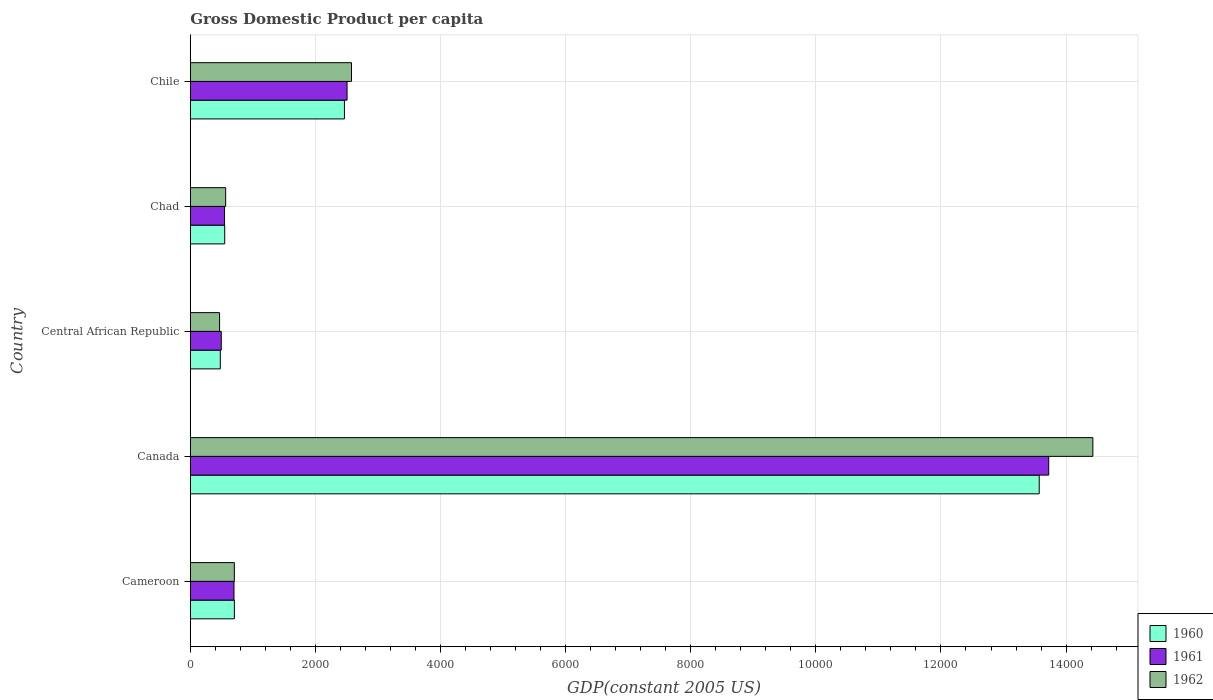How many groups of bars are there?
Your answer should be compact. 5. Are the number of bars on each tick of the Y-axis equal?
Your answer should be very brief. Yes. How many bars are there on the 5th tick from the bottom?
Ensure brevity in your answer.  3. What is the label of the 3rd group of bars from the top?
Offer a terse response. Central African Republic. What is the GDP per capita in 1961 in Cameroon?
Provide a short and direct response. 698.37. Across all countries, what is the maximum GDP per capita in 1960?
Keep it short and to the point. 1.36e+04. Across all countries, what is the minimum GDP per capita in 1962?
Make the answer very short. 468.21. In which country was the GDP per capita in 1962 minimum?
Keep it short and to the point. Central African Republic. What is the total GDP per capita in 1962 in the graph?
Keep it short and to the point. 1.87e+04. What is the difference between the GDP per capita in 1961 in Cameroon and that in Central African Republic?
Give a very brief answer. 203.38. What is the difference between the GDP per capita in 1962 in Central African Republic and the GDP per capita in 1960 in Canada?
Offer a terse response. -1.31e+04. What is the average GDP per capita in 1960 per country?
Ensure brevity in your answer.  3553.91. What is the difference between the GDP per capita in 1960 and GDP per capita in 1962 in Canada?
Ensure brevity in your answer.  -857.65. What is the ratio of the GDP per capita in 1961 in Cameroon to that in Central African Republic?
Your answer should be very brief. 1.41. Is the GDP per capita in 1960 in Canada less than that in Central African Republic?
Provide a short and direct response. No. Is the difference between the GDP per capita in 1960 in Canada and Chad greater than the difference between the GDP per capita in 1962 in Canada and Chad?
Give a very brief answer. No. What is the difference between the highest and the second highest GDP per capita in 1961?
Keep it short and to the point. 1.12e+04. What is the difference between the highest and the lowest GDP per capita in 1962?
Provide a short and direct response. 1.40e+04. Is the sum of the GDP per capita in 1960 in Central African Republic and Chad greater than the maximum GDP per capita in 1961 across all countries?
Your answer should be very brief. No. What does the 2nd bar from the top in Cameroon represents?
Your answer should be compact. 1961. What does the 1st bar from the bottom in Canada represents?
Offer a terse response. 1960. How many bars are there?
Ensure brevity in your answer.  15. How many countries are there in the graph?
Provide a succinct answer. 5. Does the graph contain any zero values?
Provide a succinct answer. No. Where does the legend appear in the graph?
Offer a terse response. Bottom right. What is the title of the graph?
Your response must be concise. Gross Domestic Product per capita. Does "2015" appear as one of the legend labels in the graph?
Keep it short and to the point. No. What is the label or title of the X-axis?
Give a very brief answer. GDP(constant 2005 US). What is the label or title of the Y-axis?
Give a very brief answer. Country. What is the GDP(constant 2005 US) in 1960 in Cameroon?
Offer a very short reply. 704.77. What is the GDP(constant 2005 US) in 1961 in Cameroon?
Your response must be concise. 698.37. What is the GDP(constant 2005 US) in 1962 in Cameroon?
Provide a short and direct response. 704.27. What is the GDP(constant 2005 US) in 1960 in Canada?
Provide a succinct answer. 1.36e+04. What is the GDP(constant 2005 US) of 1961 in Canada?
Provide a succinct answer. 1.37e+04. What is the GDP(constant 2005 US) of 1962 in Canada?
Your answer should be compact. 1.44e+04. What is the GDP(constant 2005 US) in 1960 in Central African Republic?
Your answer should be very brief. 479.7. What is the GDP(constant 2005 US) of 1961 in Central African Republic?
Keep it short and to the point. 494.99. What is the GDP(constant 2005 US) of 1962 in Central African Republic?
Make the answer very short. 468.21. What is the GDP(constant 2005 US) of 1960 in Chad?
Your answer should be compact. 550.24. What is the GDP(constant 2005 US) in 1961 in Chad?
Your response must be concise. 547.21. What is the GDP(constant 2005 US) in 1962 in Chad?
Your answer should be very brief. 565.29. What is the GDP(constant 2005 US) of 1960 in Chile?
Provide a short and direct response. 2464.15. What is the GDP(constant 2005 US) in 1961 in Chile?
Keep it short and to the point. 2506.04. What is the GDP(constant 2005 US) of 1962 in Chile?
Offer a very short reply. 2577.05. Across all countries, what is the maximum GDP(constant 2005 US) of 1960?
Your answer should be very brief. 1.36e+04. Across all countries, what is the maximum GDP(constant 2005 US) of 1961?
Keep it short and to the point. 1.37e+04. Across all countries, what is the maximum GDP(constant 2005 US) in 1962?
Give a very brief answer. 1.44e+04. Across all countries, what is the minimum GDP(constant 2005 US) in 1960?
Offer a very short reply. 479.7. Across all countries, what is the minimum GDP(constant 2005 US) in 1961?
Provide a succinct answer. 494.99. Across all countries, what is the minimum GDP(constant 2005 US) of 1962?
Ensure brevity in your answer.  468.21. What is the total GDP(constant 2005 US) of 1960 in the graph?
Offer a very short reply. 1.78e+04. What is the total GDP(constant 2005 US) of 1961 in the graph?
Make the answer very short. 1.80e+04. What is the total GDP(constant 2005 US) in 1962 in the graph?
Your response must be concise. 1.87e+04. What is the difference between the GDP(constant 2005 US) of 1960 in Cameroon and that in Canada?
Give a very brief answer. -1.29e+04. What is the difference between the GDP(constant 2005 US) in 1961 in Cameroon and that in Canada?
Make the answer very short. -1.30e+04. What is the difference between the GDP(constant 2005 US) of 1962 in Cameroon and that in Canada?
Provide a succinct answer. -1.37e+04. What is the difference between the GDP(constant 2005 US) in 1960 in Cameroon and that in Central African Republic?
Offer a very short reply. 225.07. What is the difference between the GDP(constant 2005 US) in 1961 in Cameroon and that in Central African Republic?
Offer a very short reply. 203.38. What is the difference between the GDP(constant 2005 US) of 1962 in Cameroon and that in Central African Republic?
Your answer should be compact. 236.06. What is the difference between the GDP(constant 2005 US) in 1960 in Cameroon and that in Chad?
Offer a very short reply. 154.53. What is the difference between the GDP(constant 2005 US) in 1961 in Cameroon and that in Chad?
Give a very brief answer. 151.16. What is the difference between the GDP(constant 2005 US) of 1962 in Cameroon and that in Chad?
Provide a succinct answer. 138.98. What is the difference between the GDP(constant 2005 US) of 1960 in Cameroon and that in Chile?
Provide a succinct answer. -1759.38. What is the difference between the GDP(constant 2005 US) in 1961 in Cameroon and that in Chile?
Provide a short and direct response. -1807.67. What is the difference between the GDP(constant 2005 US) of 1962 in Cameroon and that in Chile?
Provide a short and direct response. -1872.78. What is the difference between the GDP(constant 2005 US) of 1960 in Canada and that in Central African Republic?
Ensure brevity in your answer.  1.31e+04. What is the difference between the GDP(constant 2005 US) in 1961 in Canada and that in Central African Republic?
Keep it short and to the point. 1.32e+04. What is the difference between the GDP(constant 2005 US) in 1962 in Canada and that in Central African Republic?
Your answer should be very brief. 1.40e+04. What is the difference between the GDP(constant 2005 US) in 1960 in Canada and that in Chad?
Provide a succinct answer. 1.30e+04. What is the difference between the GDP(constant 2005 US) in 1961 in Canada and that in Chad?
Give a very brief answer. 1.32e+04. What is the difference between the GDP(constant 2005 US) in 1962 in Canada and that in Chad?
Offer a very short reply. 1.39e+04. What is the difference between the GDP(constant 2005 US) of 1960 in Canada and that in Chile?
Make the answer very short. 1.11e+04. What is the difference between the GDP(constant 2005 US) of 1961 in Canada and that in Chile?
Give a very brief answer. 1.12e+04. What is the difference between the GDP(constant 2005 US) in 1962 in Canada and that in Chile?
Your answer should be compact. 1.19e+04. What is the difference between the GDP(constant 2005 US) of 1960 in Central African Republic and that in Chad?
Your response must be concise. -70.54. What is the difference between the GDP(constant 2005 US) in 1961 in Central African Republic and that in Chad?
Give a very brief answer. -52.22. What is the difference between the GDP(constant 2005 US) of 1962 in Central African Republic and that in Chad?
Give a very brief answer. -97.08. What is the difference between the GDP(constant 2005 US) in 1960 in Central African Republic and that in Chile?
Provide a short and direct response. -1984.45. What is the difference between the GDP(constant 2005 US) of 1961 in Central African Republic and that in Chile?
Your response must be concise. -2011.05. What is the difference between the GDP(constant 2005 US) of 1962 in Central African Republic and that in Chile?
Your answer should be compact. -2108.84. What is the difference between the GDP(constant 2005 US) of 1960 in Chad and that in Chile?
Provide a succinct answer. -1913.91. What is the difference between the GDP(constant 2005 US) in 1961 in Chad and that in Chile?
Provide a short and direct response. -1958.84. What is the difference between the GDP(constant 2005 US) in 1962 in Chad and that in Chile?
Provide a short and direct response. -2011.76. What is the difference between the GDP(constant 2005 US) of 1960 in Cameroon and the GDP(constant 2005 US) of 1961 in Canada?
Your answer should be very brief. -1.30e+04. What is the difference between the GDP(constant 2005 US) of 1960 in Cameroon and the GDP(constant 2005 US) of 1962 in Canada?
Offer a terse response. -1.37e+04. What is the difference between the GDP(constant 2005 US) of 1961 in Cameroon and the GDP(constant 2005 US) of 1962 in Canada?
Your response must be concise. -1.37e+04. What is the difference between the GDP(constant 2005 US) in 1960 in Cameroon and the GDP(constant 2005 US) in 1961 in Central African Republic?
Ensure brevity in your answer.  209.78. What is the difference between the GDP(constant 2005 US) of 1960 in Cameroon and the GDP(constant 2005 US) of 1962 in Central African Republic?
Make the answer very short. 236.56. What is the difference between the GDP(constant 2005 US) in 1961 in Cameroon and the GDP(constant 2005 US) in 1962 in Central African Republic?
Your answer should be compact. 230.16. What is the difference between the GDP(constant 2005 US) in 1960 in Cameroon and the GDP(constant 2005 US) in 1961 in Chad?
Your answer should be very brief. 157.56. What is the difference between the GDP(constant 2005 US) of 1960 in Cameroon and the GDP(constant 2005 US) of 1962 in Chad?
Provide a succinct answer. 139.48. What is the difference between the GDP(constant 2005 US) in 1961 in Cameroon and the GDP(constant 2005 US) in 1962 in Chad?
Your answer should be compact. 133.08. What is the difference between the GDP(constant 2005 US) of 1960 in Cameroon and the GDP(constant 2005 US) of 1961 in Chile?
Make the answer very short. -1801.28. What is the difference between the GDP(constant 2005 US) in 1960 in Cameroon and the GDP(constant 2005 US) in 1962 in Chile?
Provide a short and direct response. -1872.29. What is the difference between the GDP(constant 2005 US) in 1961 in Cameroon and the GDP(constant 2005 US) in 1962 in Chile?
Keep it short and to the point. -1878.68. What is the difference between the GDP(constant 2005 US) of 1960 in Canada and the GDP(constant 2005 US) of 1961 in Central African Republic?
Make the answer very short. 1.31e+04. What is the difference between the GDP(constant 2005 US) of 1960 in Canada and the GDP(constant 2005 US) of 1962 in Central African Republic?
Your answer should be compact. 1.31e+04. What is the difference between the GDP(constant 2005 US) in 1961 in Canada and the GDP(constant 2005 US) in 1962 in Central African Republic?
Offer a very short reply. 1.33e+04. What is the difference between the GDP(constant 2005 US) in 1960 in Canada and the GDP(constant 2005 US) in 1961 in Chad?
Ensure brevity in your answer.  1.30e+04. What is the difference between the GDP(constant 2005 US) of 1960 in Canada and the GDP(constant 2005 US) of 1962 in Chad?
Give a very brief answer. 1.30e+04. What is the difference between the GDP(constant 2005 US) of 1961 in Canada and the GDP(constant 2005 US) of 1962 in Chad?
Your answer should be compact. 1.32e+04. What is the difference between the GDP(constant 2005 US) of 1960 in Canada and the GDP(constant 2005 US) of 1961 in Chile?
Keep it short and to the point. 1.11e+04. What is the difference between the GDP(constant 2005 US) in 1960 in Canada and the GDP(constant 2005 US) in 1962 in Chile?
Your response must be concise. 1.10e+04. What is the difference between the GDP(constant 2005 US) in 1961 in Canada and the GDP(constant 2005 US) in 1962 in Chile?
Your answer should be very brief. 1.11e+04. What is the difference between the GDP(constant 2005 US) of 1960 in Central African Republic and the GDP(constant 2005 US) of 1961 in Chad?
Your answer should be compact. -67.51. What is the difference between the GDP(constant 2005 US) of 1960 in Central African Republic and the GDP(constant 2005 US) of 1962 in Chad?
Provide a succinct answer. -85.59. What is the difference between the GDP(constant 2005 US) in 1961 in Central African Republic and the GDP(constant 2005 US) in 1962 in Chad?
Give a very brief answer. -70.3. What is the difference between the GDP(constant 2005 US) in 1960 in Central African Republic and the GDP(constant 2005 US) in 1961 in Chile?
Your answer should be very brief. -2026.34. What is the difference between the GDP(constant 2005 US) in 1960 in Central African Republic and the GDP(constant 2005 US) in 1962 in Chile?
Keep it short and to the point. -2097.35. What is the difference between the GDP(constant 2005 US) of 1961 in Central African Republic and the GDP(constant 2005 US) of 1962 in Chile?
Ensure brevity in your answer.  -2082.06. What is the difference between the GDP(constant 2005 US) in 1960 in Chad and the GDP(constant 2005 US) in 1961 in Chile?
Provide a succinct answer. -1955.81. What is the difference between the GDP(constant 2005 US) in 1960 in Chad and the GDP(constant 2005 US) in 1962 in Chile?
Provide a succinct answer. -2026.81. What is the difference between the GDP(constant 2005 US) of 1961 in Chad and the GDP(constant 2005 US) of 1962 in Chile?
Your response must be concise. -2029.84. What is the average GDP(constant 2005 US) in 1960 per country?
Ensure brevity in your answer.  3553.91. What is the average GDP(constant 2005 US) of 1961 per country?
Offer a terse response. 3593.84. What is the average GDP(constant 2005 US) of 1962 per country?
Your answer should be compact. 3748.64. What is the difference between the GDP(constant 2005 US) of 1960 and GDP(constant 2005 US) of 1961 in Cameroon?
Make the answer very short. 6.4. What is the difference between the GDP(constant 2005 US) in 1960 and GDP(constant 2005 US) in 1962 in Cameroon?
Provide a succinct answer. 0.5. What is the difference between the GDP(constant 2005 US) in 1961 and GDP(constant 2005 US) in 1962 in Cameroon?
Keep it short and to the point. -5.9. What is the difference between the GDP(constant 2005 US) in 1960 and GDP(constant 2005 US) in 1961 in Canada?
Your response must be concise. -151.91. What is the difference between the GDP(constant 2005 US) of 1960 and GDP(constant 2005 US) of 1962 in Canada?
Make the answer very short. -857.65. What is the difference between the GDP(constant 2005 US) of 1961 and GDP(constant 2005 US) of 1962 in Canada?
Your answer should be compact. -705.75. What is the difference between the GDP(constant 2005 US) of 1960 and GDP(constant 2005 US) of 1961 in Central African Republic?
Offer a very short reply. -15.29. What is the difference between the GDP(constant 2005 US) of 1960 and GDP(constant 2005 US) of 1962 in Central African Republic?
Offer a very short reply. 11.49. What is the difference between the GDP(constant 2005 US) of 1961 and GDP(constant 2005 US) of 1962 in Central African Republic?
Provide a short and direct response. 26.78. What is the difference between the GDP(constant 2005 US) in 1960 and GDP(constant 2005 US) in 1961 in Chad?
Keep it short and to the point. 3.03. What is the difference between the GDP(constant 2005 US) in 1960 and GDP(constant 2005 US) in 1962 in Chad?
Your answer should be very brief. -15.05. What is the difference between the GDP(constant 2005 US) of 1961 and GDP(constant 2005 US) of 1962 in Chad?
Your response must be concise. -18.08. What is the difference between the GDP(constant 2005 US) in 1960 and GDP(constant 2005 US) in 1961 in Chile?
Keep it short and to the point. -41.89. What is the difference between the GDP(constant 2005 US) of 1960 and GDP(constant 2005 US) of 1962 in Chile?
Your answer should be compact. -112.9. What is the difference between the GDP(constant 2005 US) of 1961 and GDP(constant 2005 US) of 1962 in Chile?
Ensure brevity in your answer.  -71.01. What is the ratio of the GDP(constant 2005 US) of 1960 in Cameroon to that in Canada?
Your answer should be very brief. 0.05. What is the ratio of the GDP(constant 2005 US) of 1961 in Cameroon to that in Canada?
Make the answer very short. 0.05. What is the ratio of the GDP(constant 2005 US) in 1962 in Cameroon to that in Canada?
Your answer should be compact. 0.05. What is the ratio of the GDP(constant 2005 US) in 1960 in Cameroon to that in Central African Republic?
Provide a short and direct response. 1.47. What is the ratio of the GDP(constant 2005 US) of 1961 in Cameroon to that in Central African Republic?
Provide a short and direct response. 1.41. What is the ratio of the GDP(constant 2005 US) in 1962 in Cameroon to that in Central African Republic?
Ensure brevity in your answer.  1.5. What is the ratio of the GDP(constant 2005 US) of 1960 in Cameroon to that in Chad?
Offer a very short reply. 1.28. What is the ratio of the GDP(constant 2005 US) in 1961 in Cameroon to that in Chad?
Ensure brevity in your answer.  1.28. What is the ratio of the GDP(constant 2005 US) of 1962 in Cameroon to that in Chad?
Give a very brief answer. 1.25. What is the ratio of the GDP(constant 2005 US) of 1960 in Cameroon to that in Chile?
Provide a short and direct response. 0.29. What is the ratio of the GDP(constant 2005 US) in 1961 in Cameroon to that in Chile?
Your answer should be compact. 0.28. What is the ratio of the GDP(constant 2005 US) in 1962 in Cameroon to that in Chile?
Keep it short and to the point. 0.27. What is the ratio of the GDP(constant 2005 US) in 1960 in Canada to that in Central African Republic?
Your response must be concise. 28.29. What is the ratio of the GDP(constant 2005 US) in 1961 in Canada to that in Central African Republic?
Offer a terse response. 27.72. What is the ratio of the GDP(constant 2005 US) in 1962 in Canada to that in Central African Republic?
Provide a short and direct response. 30.82. What is the ratio of the GDP(constant 2005 US) in 1960 in Canada to that in Chad?
Ensure brevity in your answer.  24.66. What is the ratio of the GDP(constant 2005 US) of 1961 in Canada to that in Chad?
Give a very brief answer. 25.08. What is the ratio of the GDP(constant 2005 US) of 1962 in Canada to that in Chad?
Ensure brevity in your answer.  25.52. What is the ratio of the GDP(constant 2005 US) of 1960 in Canada to that in Chile?
Provide a short and direct response. 5.51. What is the ratio of the GDP(constant 2005 US) in 1961 in Canada to that in Chile?
Keep it short and to the point. 5.48. What is the ratio of the GDP(constant 2005 US) in 1962 in Canada to that in Chile?
Provide a succinct answer. 5.6. What is the ratio of the GDP(constant 2005 US) in 1960 in Central African Republic to that in Chad?
Your response must be concise. 0.87. What is the ratio of the GDP(constant 2005 US) in 1961 in Central African Republic to that in Chad?
Provide a succinct answer. 0.9. What is the ratio of the GDP(constant 2005 US) of 1962 in Central African Republic to that in Chad?
Give a very brief answer. 0.83. What is the ratio of the GDP(constant 2005 US) of 1960 in Central African Republic to that in Chile?
Give a very brief answer. 0.19. What is the ratio of the GDP(constant 2005 US) of 1961 in Central African Republic to that in Chile?
Offer a terse response. 0.2. What is the ratio of the GDP(constant 2005 US) of 1962 in Central African Republic to that in Chile?
Your answer should be compact. 0.18. What is the ratio of the GDP(constant 2005 US) of 1960 in Chad to that in Chile?
Ensure brevity in your answer.  0.22. What is the ratio of the GDP(constant 2005 US) in 1961 in Chad to that in Chile?
Offer a very short reply. 0.22. What is the ratio of the GDP(constant 2005 US) in 1962 in Chad to that in Chile?
Provide a short and direct response. 0.22. What is the difference between the highest and the second highest GDP(constant 2005 US) in 1960?
Your answer should be very brief. 1.11e+04. What is the difference between the highest and the second highest GDP(constant 2005 US) of 1961?
Your response must be concise. 1.12e+04. What is the difference between the highest and the second highest GDP(constant 2005 US) in 1962?
Your response must be concise. 1.19e+04. What is the difference between the highest and the lowest GDP(constant 2005 US) of 1960?
Provide a succinct answer. 1.31e+04. What is the difference between the highest and the lowest GDP(constant 2005 US) of 1961?
Offer a terse response. 1.32e+04. What is the difference between the highest and the lowest GDP(constant 2005 US) in 1962?
Keep it short and to the point. 1.40e+04. 